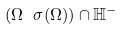<formula> <loc_0><loc_0><loc_500><loc_500>( \Omega \ \sigma ( \Omega ) ) \cap \mathbb { H } ^ { - }</formula> 